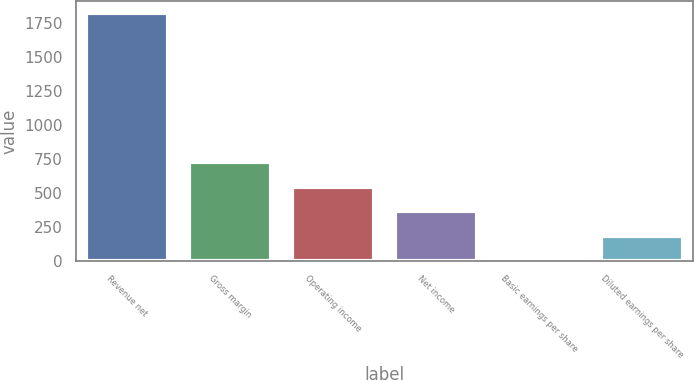Convert chart to OTSL. <chart><loc_0><loc_0><loc_500><loc_500><bar_chart><fcel>Revenue net<fcel>Gross margin<fcel>Operating income<fcel>Net income<fcel>Basic earnings per share<fcel>Diluted earnings per share<nl><fcel>1823<fcel>729.22<fcel>546.93<fcel>364.64<fcel>0.06<fcel>182.35<nl></chart> 